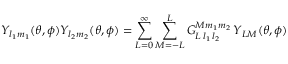Convert formula to latex. <formula><loc_0><loc_0><loc_500><loc_500>Y _ { l _ { 1 } m _ { 1 } } ( \theta , \phi ) Y _ { l _ { 2 } m _ { 2 } } ( \theta , \phi ) = \sum _ { L = 0 } ^ { \infty } \sum _ { M = - L } ^ { L } G _ { L \, l _ { 1 } \, l _ { 2 } } ^ { M m _ { 1 } m _ { 2 } } \, Y _ { L M } ( \theta , \phi )</formula> 